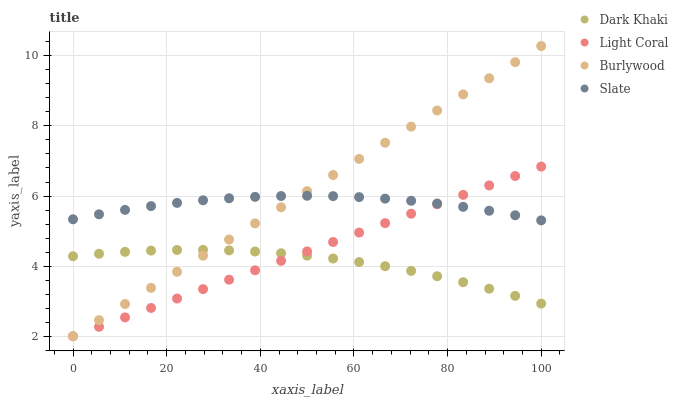Does Dark Khaki have the minimum area under the curve?
Answer yes or no. Yes. Does Burlywood have the maximum area under the curve?
Answer yes or no. Yes. Does Light Coral have the minimum area under the curve?
Answer yes or no. No. Does Light Coral have the maximum area under the curve?
Answer yes or no. No. Is Light Coral the smoothest?
Answer yes or no. Yes. Is Dark Khaki the roughest?
Answer yes or no. Yes. Is Slate the smoothest?
Answer yes or no. No. Is Slate the roughest?
Answer yes or no. No. Does Light Coral have the lowest value?
Answer yes or no. Yes. Does Slate have the lowest value?
Answer yes or no. No. Does Burlywood have the highest value?
Answer yes or no. Yes. Does Light Coral have the highest value?
Answer yes or no. No. Is Dark Khaki less than Slate?
Answer yes or no. Yes. Is Slate greater than Dark Khaki?
Answer yes or no. Yes. Does Burlywood intersect Dark Khaki?
Answer yes or no. Yes. Is Burlywood less than Dark Khaki?
Answer yes or no. No. Is Burlywood greater than Dark Khaki?
Answer yes or no. No. Does Dark Khaki intersect Slate?
Answer yes or no. No. 